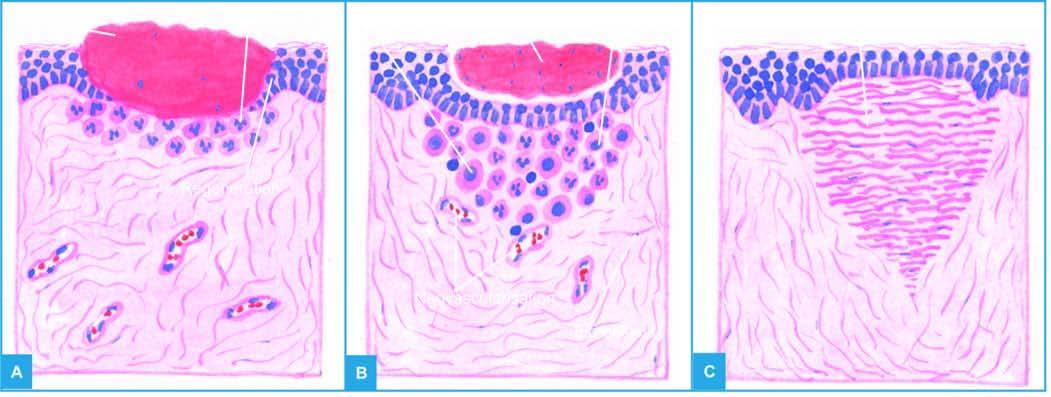what is left after contraction of the wound?
Answer the question using a single word or phrase. A scar smaller than the original wound 